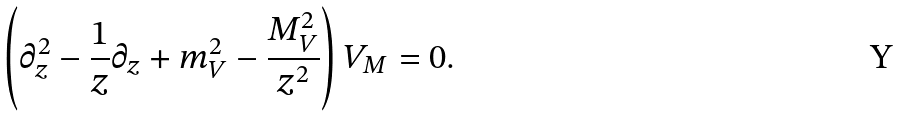Convert formula to latex. <formula><loc_0><loc_0><loc_500><loc_500>\left ( \partial _ { z } ^ { 2 } - \frac { 1 } { z } \partial _ { z } + m _ { V } ^ { 2 } - \frac { M _ { V } ^ { 2 } } { z ^ { 2 } } \right ) V _ { M } = 0 .</formula> 